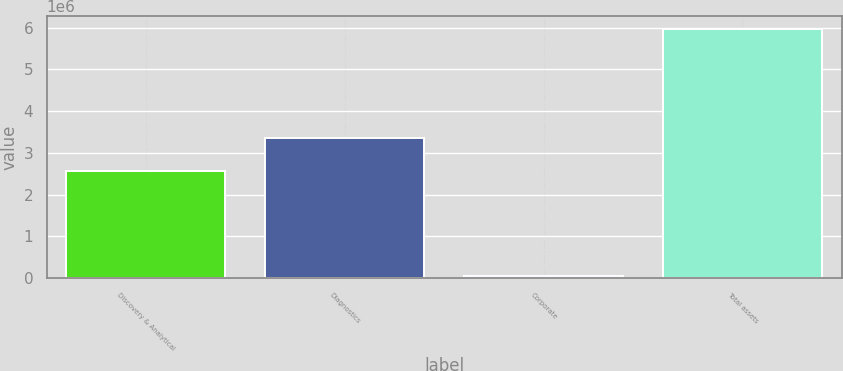Convert chart to OTSL. <chart><loc_0><loc_0><loc_500><loc_500><bar_chart><fcel>Discovery & Analytical<fcel>Diagnostics<fcel>Corporate<fcel>Total assets<nl><fcel>2.56705e+06<fcel>3.35896e+06<fcel>49504<fcel>5.97552e+06<nl></chart> 